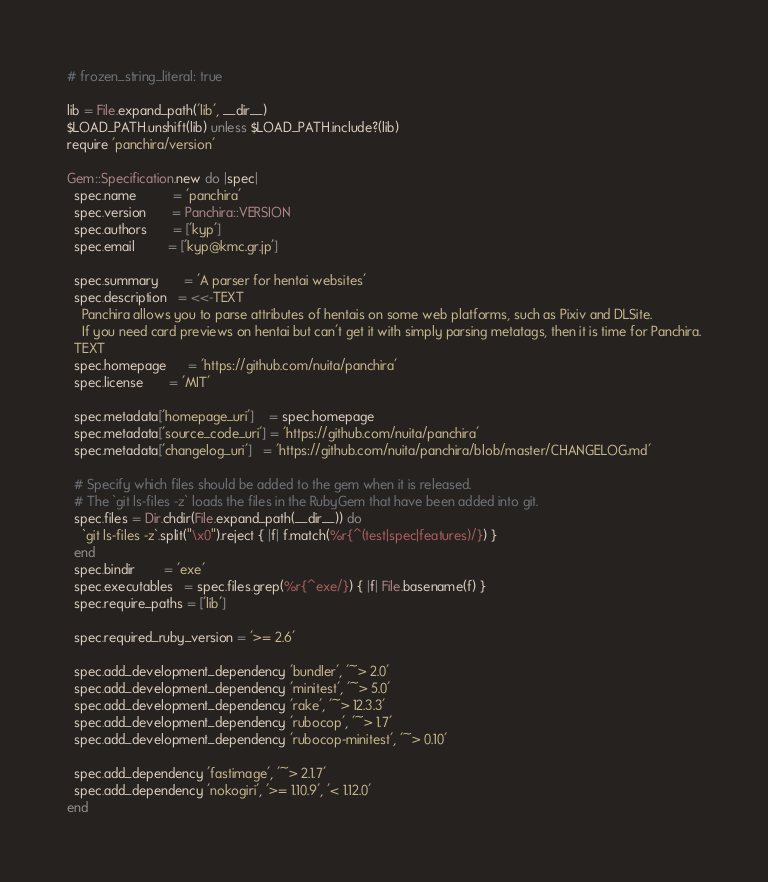<code> <loc_0><loc_0><loc_500><loc_500><_Ruby_># frozen_string_literal: true

lib = File.expand_path('lib', __dir__)
$LOAD_PATH.unshift(lib) unless $LOAD_PATH.include?(lib)
require 'panchira/version'

Gem::Specification.new do |spec|
  spec.name          = 'panchira'
  spec.version       = Panchira::VERSION
  spec.authors       = ['kyp']
  spec.email         = ['kyp@kmc.gr.jp']

  spec.summary       = 'A parser for hentai websites'
  spec.description   = <<-TEXT
    Panchira allows you to parse attributes of hentais on some web platforms, such as Pixiv and DLSite.
    If you need card previews on hentai but can't get it with simply parsing metatags, then it is time for Panchira.
  TEXT
  spec.homepage      = 'https://github.com/nuita/panchira'
  spec.license       = 'MIT'

  spec.metadata['homepage_uri']    = spec.homepage
  spec.metadata['source_code_uri'] = 'https://github.com/nuita/panchira'
  spec.metadata['changelog_uri']   = 'https://github.com/nuita/panchira/blob/master/CHANGELOG.md'

  # Specify which files should be added to the gem when it is released.
  # The `git ls-files -z` loads the files in the RubyGem that have been added into git.
  spec.files = Dir.chdir(File.expand_path(__dir__)) do
    `git ls-files -z`.split("\x0").reject { |f| f.match(%r{^(test|spec|features)/}) }
  end
  spec.bindir        = 'exe'
  spec.executables   = spec.files.grep(%r{^exe/}) { |f| File.basename(f) }
  spec.require_paths = ['lib']

  spec.required_ruby_version = '>= 2.6'

  spec.add_development_dependency 'bundler', '~> 2.0'
  spec.add_development_dependency 'minitest', '~> 5.0'
  spec.add_development_dependency 'rake', '~> 12.3.3'
  spec.add_development_dependency 'rubocop', '~> 1.7'
  spec.add_development_dependency 'rubocop-minitest', '~> 0.10'

  spec.add_dependency 'fastimage', '~> 2.1.7'
  spec.add_dependency 'nokogiri', '>= 1.10.9', '< 1.12.0'
end
</code> 